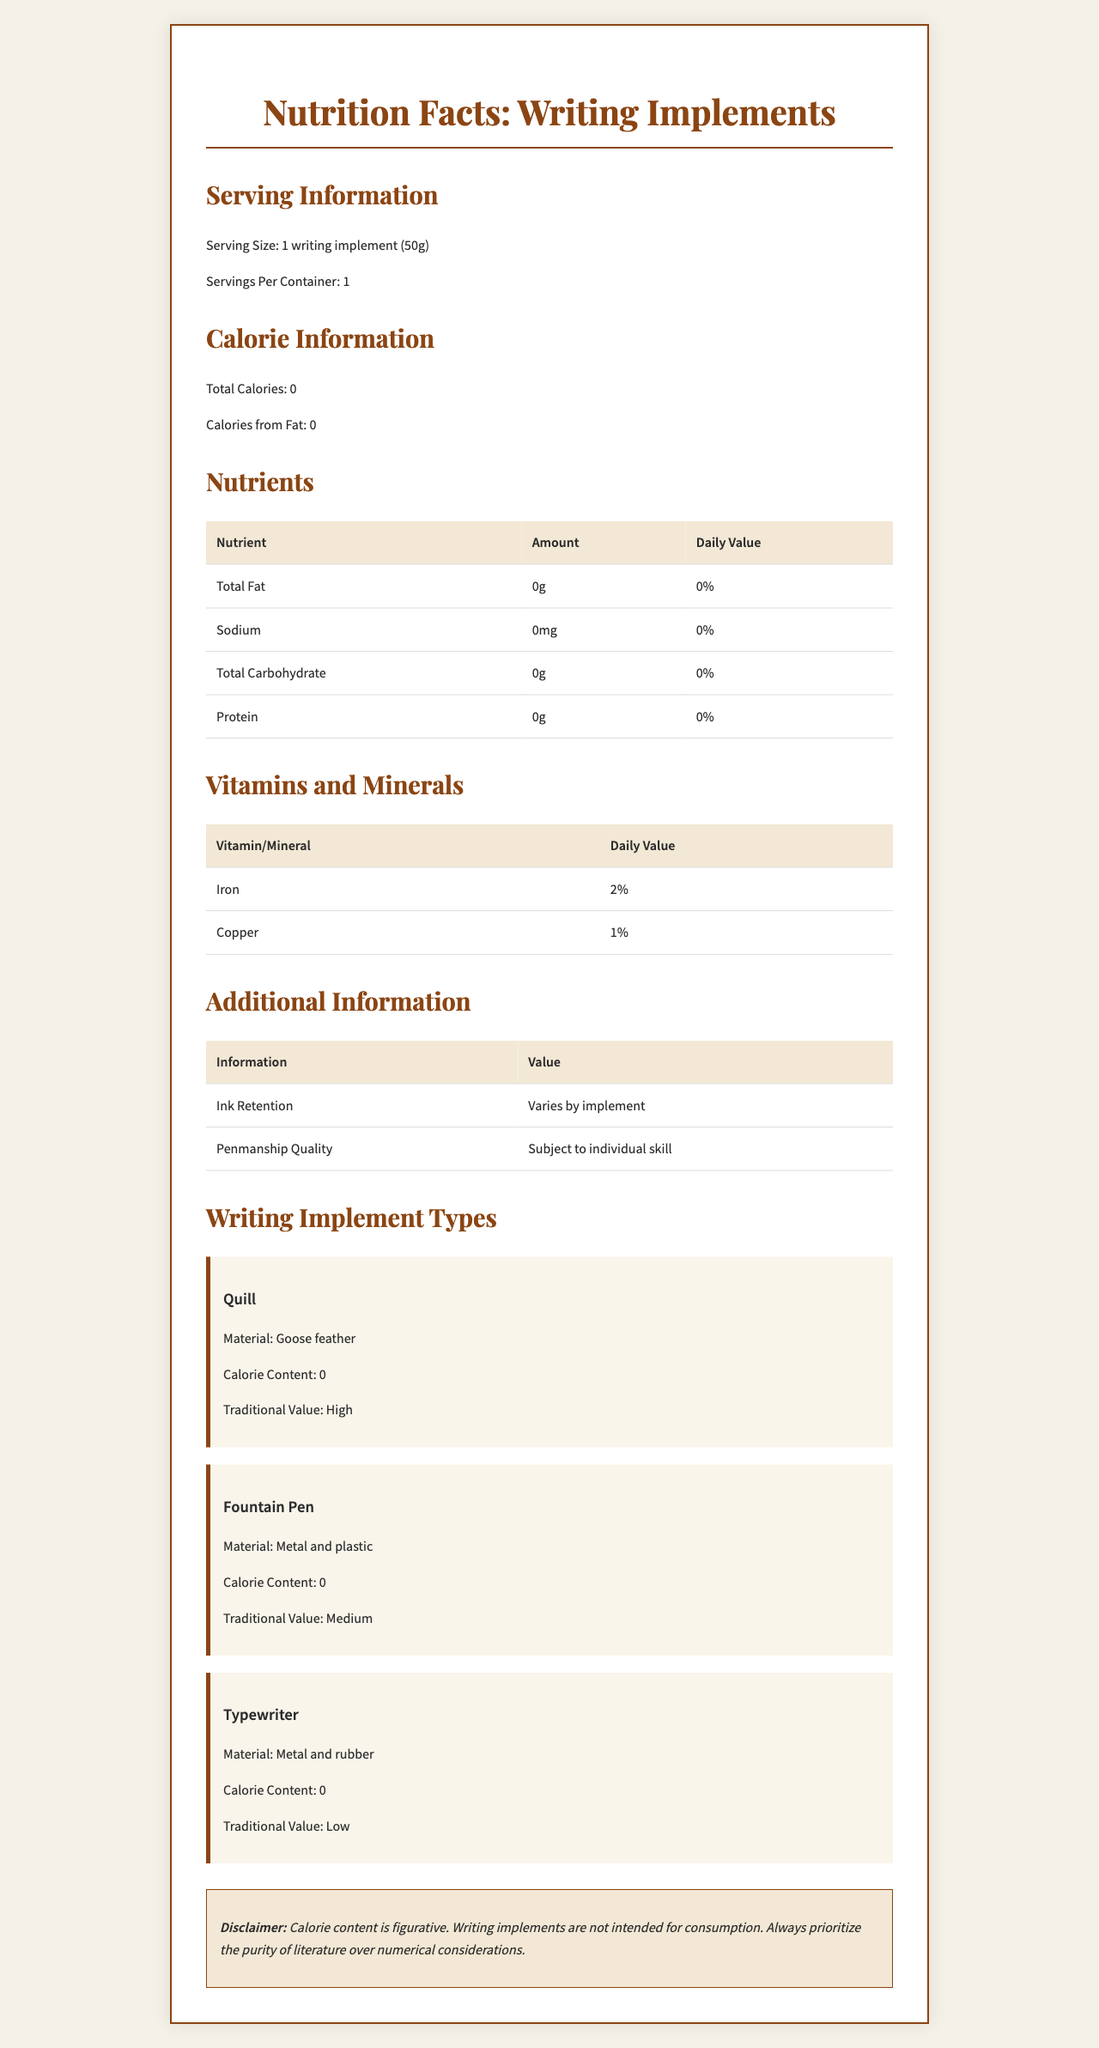what is the serving size mentioned in the document? The document states "Serving Size: 1 writing implement (50g)" under the Serving Information section.
Answer: 1 writing implement (50g) how many servings per container are listed? The Servings Per Container value in the Serving Information section is 1.
Answer: 1 are there any calories in the writing implements? Under Calorie Information, both Total Calories and Calories from Fat are listed as 0.
Answer: No which nutrient has the highest daily value percentage listed? The Vitamins and Minerals section shows Iron with a 2% daily value, higher than Copper's 1%.
Answer: Iron what is one unique feature about the 'Quill' as a writing implement? In the Writing Implement Types section, the Quill is described as being made from a "Goose feather."
Answer: Material: Goose feather which writing implement has the lowest traditional value? The Traditional Value for the Typewriter is indicated as "Low" in the Writing Implement Types section.
Answer: Typewriter what is the daily value percentage of Copper? The Vitamins and Minerals table lists the daily value percentage of Copper as 1%.
Answer: 1% which of the following does NOT contain any calories? A. Quill B. Fountain Pen C. Typewriter D. All of the above The Calorie Content for Quill, Fountain Pen, and Typewriter is listed as 0 in the document.
Answer: D. All of the above how is penmanship quality determined according to the document? The Additional Information table notes that Penmanship Quality is "Subject to individual skill."
Answer: Subject to individual skill does the document state the exact calorie content for 'Ink Retention'? The document notes that "Ink Retention" varies by implement and doesn't provide an exact calorie content.
Answer: No what is one reason someone might choose a Quill over a Typewriter based on traditional value? The Quill has a "High" Traditional Value compared to the Typewriter's "Low" Traditional Value, which might appeal to a traditionalist.
Answer: High Traditional Value summarize the main idea of this document. This document mimics a nutrition facts label to humorously present details about different writing implements, including their materials, calorie content, and other notable characteristics.
Answer: The document provides a nutrition facts-style analysis of various writing implements, listing their calorie content, nutrients, additional information, and traditional value. what is the main difference in material between a Fountain Pen and a Quill? The Writing Implement Types section lists the materials for Fountain Pen as metal and plastic, while the Quill is made of goose feather.
Answer: Fountain Pen: Metal and plastic, Quill: Goose feather is calorie content for the writing implements figurative? The disclaimer states that the calorie content is figurative and that writing implements are not intended for consumption.
Answer: Yes which writing implement has the greatest variability in ink retention? A. Quill B. Fountain Pen C. Typewriter D. All vary equally The document states, "Ink Retention varies by implement," but does not specify which has the greatest variability.
Answer: Not enough information 